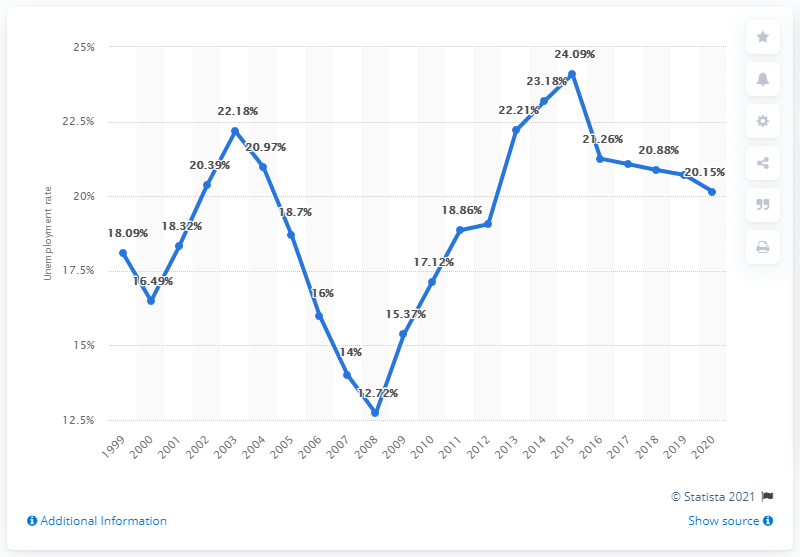Highlight a few significant elements in this photo. The unemployment rate in St. Lucia in 2020 was 20.15%. 